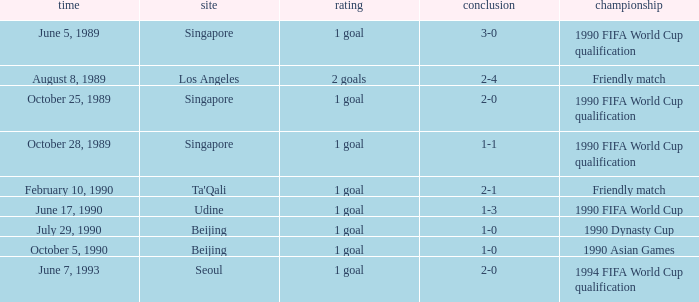What was the score of the match with a 3-0 result? 1 goal. 